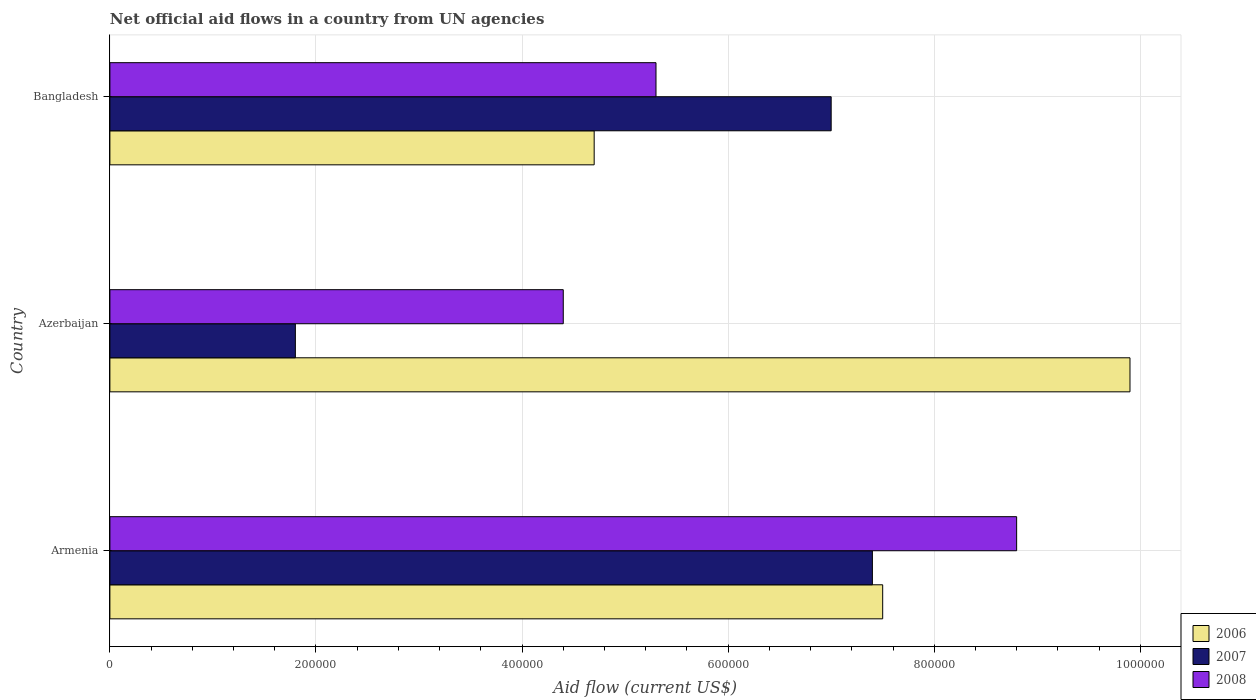What is the label of the 2nd group of bars from the top?
Offer a terse response. Azerbaijan. In how many cases, is the number of bars for a given country not equal to the number of legend labels?
Provide a short and direct response. 0. What is the net official aid flow in 2007 in Armenia?
Ensure brevity in your answer.  7.40e+05. Across all countries, what is the maximum net official aid flow in 2007?
Offer a very short reply. 7.40e+05. Across all countries, what is the minimum net official aid flow in 2007?
Your answer should be very brief. 1.80e+05. In which country was the net official aid flow in 2007 maximum?
Provide a short and direct response. Armenia. In which country was the net official aid flow in 2006 minimum?
Provide a short and direct response. Bangladesh. What is the total net official aid flow in 2006 in the graph?
Keep it short and to the point. 2.21e+06. What is the difference between the net official aid flow in 2006 in Armenia and that in Azerbaijan?
Give a very brief answer. -2.40e+05. What is the difference between the net official aid flow in 2008 in Bangladesh and the net official aid flow in 2007 in Armenia?
Keep it short and to the point. -2.10e+05. What is the average net official aid flow in 2008 per country?
Offer a terse response. 6.17e+05. What is the ratio of the net official aid flow in 2008 in Armenia to that in Bangladesh?
Your answer should be very brief. 1.66. Is the net official aid flow in 2008 in Armenia less than that in Azerbaijan?
Give a very brief answer. No. Is the difference between the net official aid flow in 2007 in Armenia and Azerbaijan greater than the difference between the net official aid flow in 2006 in Armenia and Azerbaijan?
Make the answer very short. Yes. What is the difference between the highest and the lowest net official aid flow in 2008?
Offer a very short reply. 4.40e+05. What does the 1st bar from the bottom in Armenia represents?
Give a very brief answer. 2006. Are the values on the major ticks of X-axis written in scientific E-notation?
Provide a succinct answer. No. Does the graph contain any zero values?
Make the answer very short. No. Does the graph contain grids?
Your answer should be very brief. Yes. Where does the legend appear in the graph?
Provide a succinct answer. Bottom right. What is the title of the graph?
Make the answer very short. Net official aid flows in a country from UN agencies. What is the label or title of the X-axis?
Keep it short and to the point. Aid flow (current US$). What is the Aid flow (current US$) of 2006 in Armenia?
Offer a very short reply. 7.50e+05. What is the Aid flow (current US$) of 2007 in Armenia?
Provide a succinct answer. 7.40e+05. What is the Aid flow (current US$) of 2008 in Armenia?
Provide a short and direct response. 8.80e+05. What is the Aid flow (current US$) in 2006 in Azerbaijan?
Your answer should be very brief. 9.90e+05. What is the Aid flow (current US$) in 2008 in Azerbaijan?
Provide a short and direct response. 4.40e+05. What is the Aid flow (current US$) in 2008 in Bangladesh?
Your answer should be very brief. 5.30e+05. Across all countries, what is the maximum Aid flow (current US$) of 2006?
Give a very brief answer. 9.90e+05. Across all countries, what is the maximum Aid flow (current US$) in 2007?
Ensure brevity in your answer.  7.40e+05. Across all countries, what is the maximum Aid flow (current US$) in 2008?
Provide a short and direct response. 8.80e+05. Across all countries, what is the minimum Aid flow (current US$) of 2006?
Offer a very short reply. 4.70e+05. What is the total Aid flow (current US$) of 2006 in the graph?
Offer a terse response. 2.21e+06. What is the total Aid flow (current US$) of 2007 in the graph?
Offer a very short reply. 1.62e+06. What is the total Aid flow (current US$) of 2008 in the graph?
Keep it short and to the point. 1.85e+06. What is the difference between the Aid flow (current US$) in 2006 in Armenia and that in Azerbaijan?
Ensure brevity in your answer.  -2.40e+05. What is the difference between the Aid flow (current US$) in 2007 in Armenia and that in Azerbaijan?
Provide a succinct answer. 5.60e+05. What is the difference between the Aid flow (current US$) in 2007 in Armenia and that in Bangladesh?
Give a very brief answer. 4.00e+04. What is the difference between the Aid flow (current US$) of 2006 in Azerbaijan and that in Bangladesh?
Your response must be concise. 5.20e+05. What is the difference between the Aid flow (current US$) in 2007 in Azerbaijan and that in Bangladesh?
Make the answer very short. -5.20e+05. What is the difference between the Aid flow (current US$) of 2006 in Armenia and the Aid flow (current US$) of 2007 in Azerbaijan?
Provide a short and direct response. 5.70e+05. What is the difference between the Aid flow (current US$) in 2006 in Armenia and the Aid flow (current US$) in 2008 in Azerbaijan?
Your answer should be compact. 3.10e+05. What is the difference between the Aid flow (current US$) in 2006 in Armenia and the Aid flow (current US$) in 2007 in Bangladesh?
Ensure brevity in your answer.  5.00e+04. What is the difference between the Aid flow (current US$) in 2006 in Azerbaijan and the Aid flow (current US$) in 2007 in Bangladesh?
Your answer should be compact. 2.90e+05. What is the difference between the Aid flow (current US$) in 2007 in Azerbaijan and the Aid flow (current US$) in 2008 in Bangladesh?
Keep it short and to the point. -3.50e+05. What is the average Aid flow (current US$) in 2006 per country?
Provide a short and direct response. 7.37e+05. What is the average Aid flow (current US$) of 2007 per country?
Your response must be concise. 5.40e+05. What is the average Aid flow (current US$) of 2008 per country?
Offer a very short reply. 6.17e+05. What is the difference between the Aid flow (current US$) in 2006 and Aid flow (current US$) in 2007 in Armenia?
Provide a succinct answer. 10000. What is the difference between the Aid flow (current US$) in 2007 and Aid flow (current US$) in 2008 in Armenia?
Keep it short and to the point. -1.40e+05. What is the difference between the Aid flow (current US$) of 2006 and Aid flow (current US$) of 2007 in Azerbaijan?
Make the answer very short. 8.10e+05. What is the difference between the Aid flow (current US$) of 2007 and Aid flow (current US$) of 2008 in Bangladesh?
Give a very brief answer. 1.70e+05. What is the ratio of the Aid flow (current US$) in 2006 in Armenia to that in Azerbaijan?
Offer a very short reply. 0.76. What is the ratio of the Aid flow (current US$) of 2007 in Armenia to that in Azerbaijan?
Provide a short and direct response. 4.11. What is the ratio of the Aid flow (current US$) of 2006 in Armenia to that in Bangladesh?
Your response must be concise. 1.6. What is the ratio of the Aid flow (current US$) of 2007 in Armenia to that in Bangladesh?
Ensure brevity in your answer.  1.06. What is the ratio of the Aid flow (current US$) of 2008 in Armenia to that in Bangladesh?
Your answer should be very brief. 1.66. What is the ratio of the Aid flow (current US$) in 2006 in Azerbaijan to that in Bangladesh?
Your answer should be very brief. 2.11. What is the ratio of the Aid flow (current US$) of 2007 in Azerbaijan to that in Bangladesh?
Give a very brief answer. 0.26. What is the ratio of the Aid flow (current US$) in 2008 in Azerbaijan to that in Bangladesh?
Provide a succinct answer. 0.83. What is the difference between the highest and the second highest Aid flow (current US$) in 2008?
Provide a succinct answer. 3.50e+05. What is the difference between the highest and the lowest Aid flow (current US$) of 2006?
Give a very brief answer. 5.20e+05. What is the difference between the highest and the lowest Aid flow (current US$) in 2007?
Your answer should be compact. 5.60e+05. 